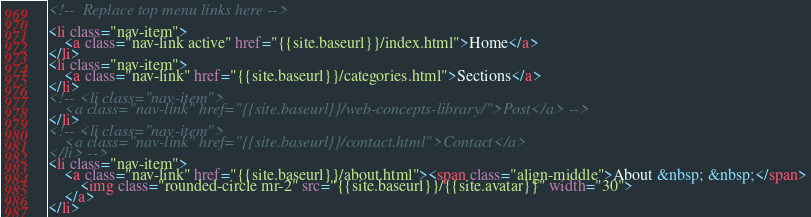<code> <loc_0><loc_0><loc_500><loc_500><_HTML_><!--  Replace top menu links here -->

<li class="nav-item">
	<a class="nav-link active" href="{{site.baseurl}}/index.html">Home</a>
</li>
<li class="nav-item">
	<a class="nav-link" href="{{site.baseurl}}/categories.html">Sections</a>
</li>
<!-- <li class="nav-item">
    <a class="nav-link" href="{{site.baseurl}}/web-concepts-library/">Post</a> -->
</li>
<!-- <li class="nav-item">
	<a class="nav-link" href="{{site.baseurl}}/contact.html">Contact</a>
</li> -->
<li class="nav-item">
	<a class="nav-link" href="{{site.baseurl}}/about.html"><span class="align-middle">About &nbsp; &nbsp;</span>
		<img class="rounded-circle mr-2" src="{{site.baseurl}}/{{site.avatar}}" width="30">
	</a>
</li></code> 